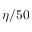<formula> <loc_0><loc_0><loc_500><loc_500>\eta / 5 0</formula> 